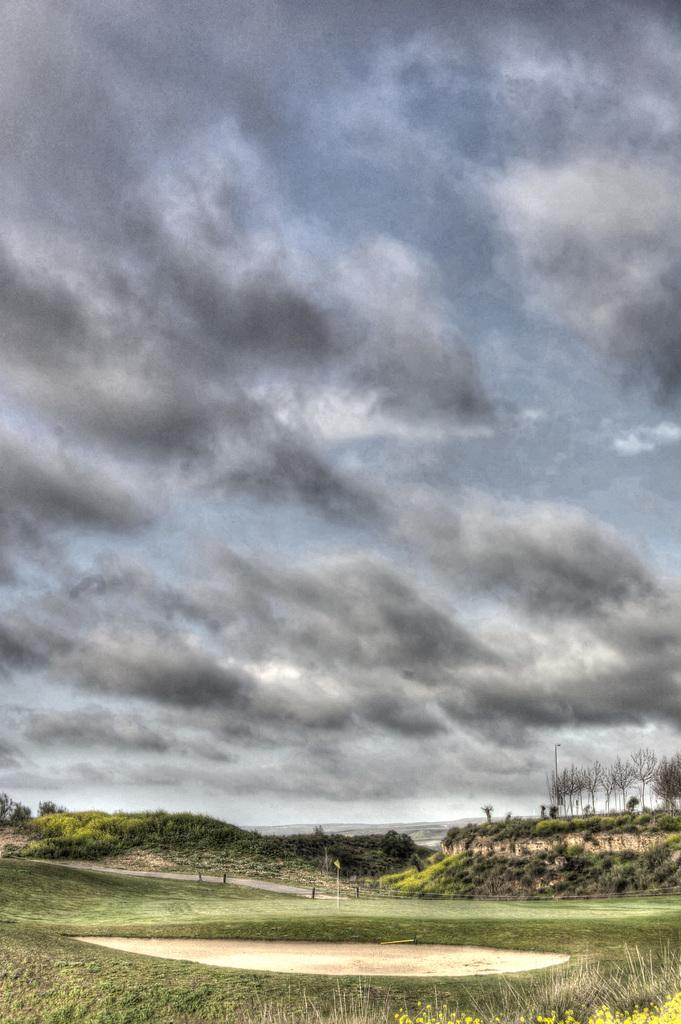What type of terrain is visible in the image? There is land visible in the image. What type of vegetation is present on the land? There is grass on the land. What type of tree can be seen on the land? There is a dry tree on the land. What is visible in the sky in the image? The sky is full of clouds. What is the name of the leg that is visible in the image? There is no leg visible in the image; it features land, grass, a dry tree, and clouds in the sky. 